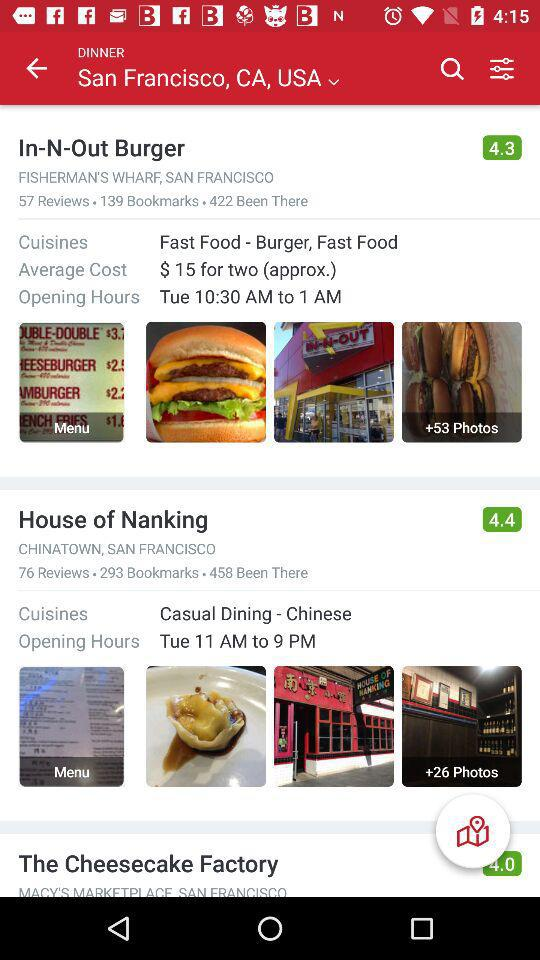How many reviews are there for the "House of Nanking"? There are 76 reviews for the "House of Nanking". 